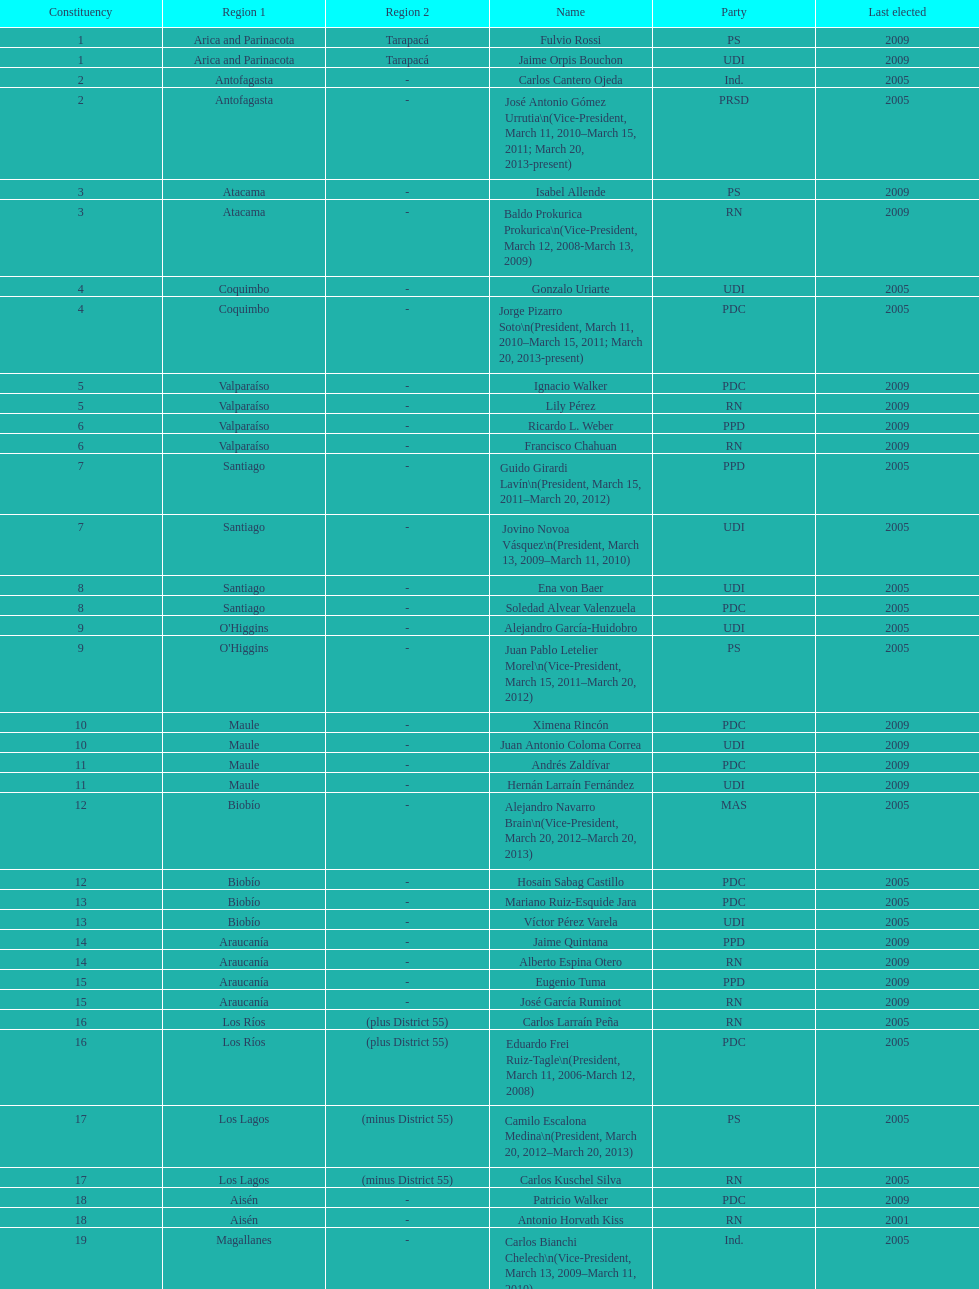What is the last region listed on the table? Magallanes. 